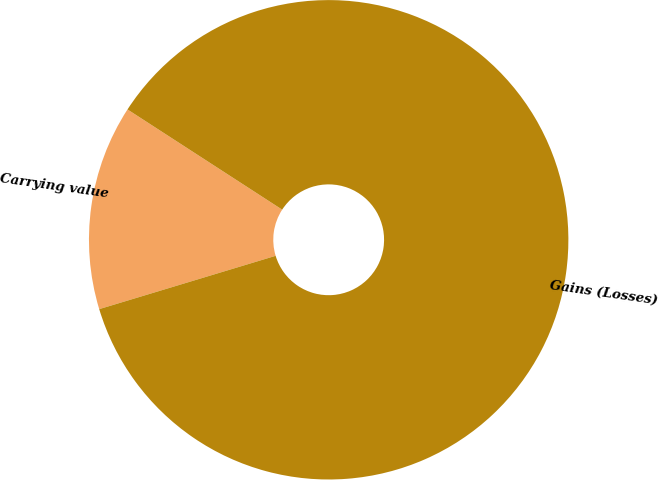Convert chart to OTSL. <chart><loc_0><loc_0><loc_500><loc_500><pie_chart><fcel>Carrying value<fcel>Gains (Losses)<nl><fcel>13.82%<fcel>86.18%<nl></chart> 